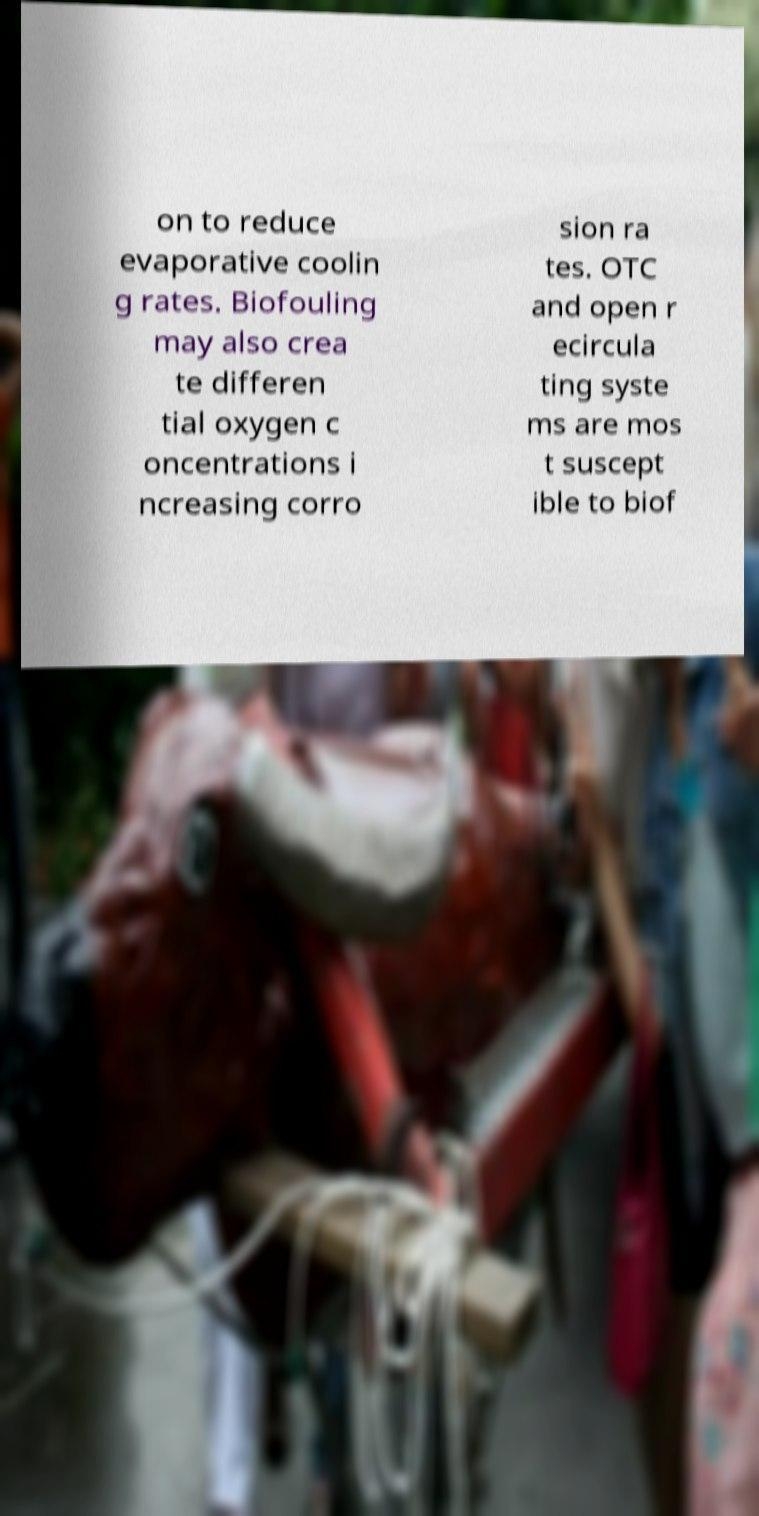Please read and relay the text visible in this image. What does it say? on to reduce evaporative coolin g rates. Biofouling may also crea te differen tial oxygen c oncentrations i ncreasing corro sion ra tes. OTC and open r ecircula ting syste ms are mos t suscept ible to biof 